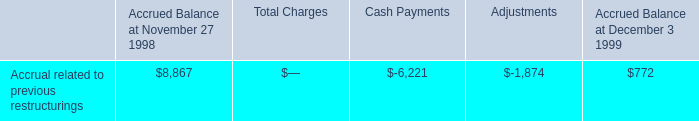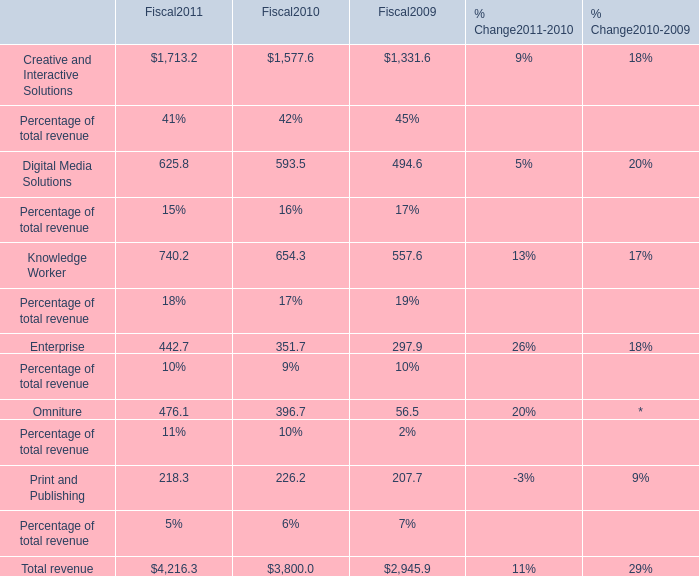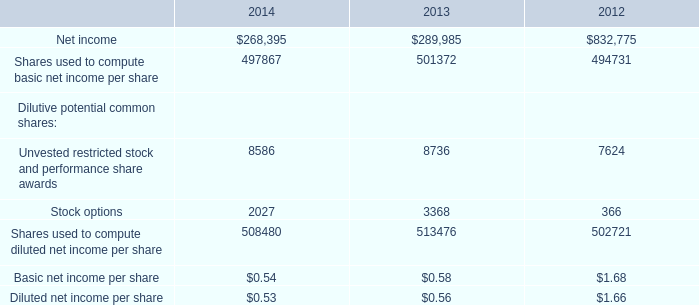for restructuring expense , what is the total balance of severance and related charges and lease termination costs in millions? 
Computations: (0.3 + 0.1)
Answer: 0.4. 